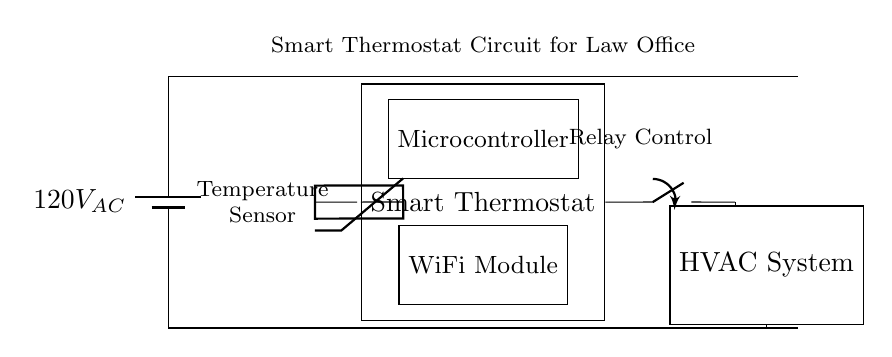What is the power supply voltage in this circuit? The power supply is indicated by the battery symbol at the top left corner of the diagram, labeled as 120V AC. This represents the input voltage for the circuit.
Answer: 120V AC What is the main function of the smart thermostat? The smart thermostat's purpose is to regulate the temperature by communicating with the HVAC system and utilizing temperature readings from the temperature sensor. This is inferred from its central placement in the circuit and connections to other components.
Answer: Regulating temperature What component controls the HVAC system? The relay controls the HVAC system, as shown by the connection from the thermostat to the closing switch, which then connects to the HVAC system. The relay acts as a switch, allowing or stopping the flow of current to the HVAC.
Answer: Relay How does the thermostat determine when to activate the HVAC system? The thermostat uses the temperature sensor, depicted on the left side, that senses the current room temperature. When the temperature deviates from the setpoint, it will trigger the microcontroller to activate the relay that powers the HVAC system.
Answer: Temperature sensor What is the purpose of the WiFi module in the circuit? The WiFi module allows the thermostat to connect to a network for remote control and monitoring. This is indicated by its labeled connection and placement in the diagram, facilitating communication beyond the local circuit.
Answer: Remote control How does the microcontroller affect the operation of the thermostat? The microcontroller processes data from the temperature sensor and makes decisions about when to activate the HVAC system by controlling the relay. This relationship is shown by its direct connection to both the thermostat and the relay in the diagram.
Answer: Controls the relay 